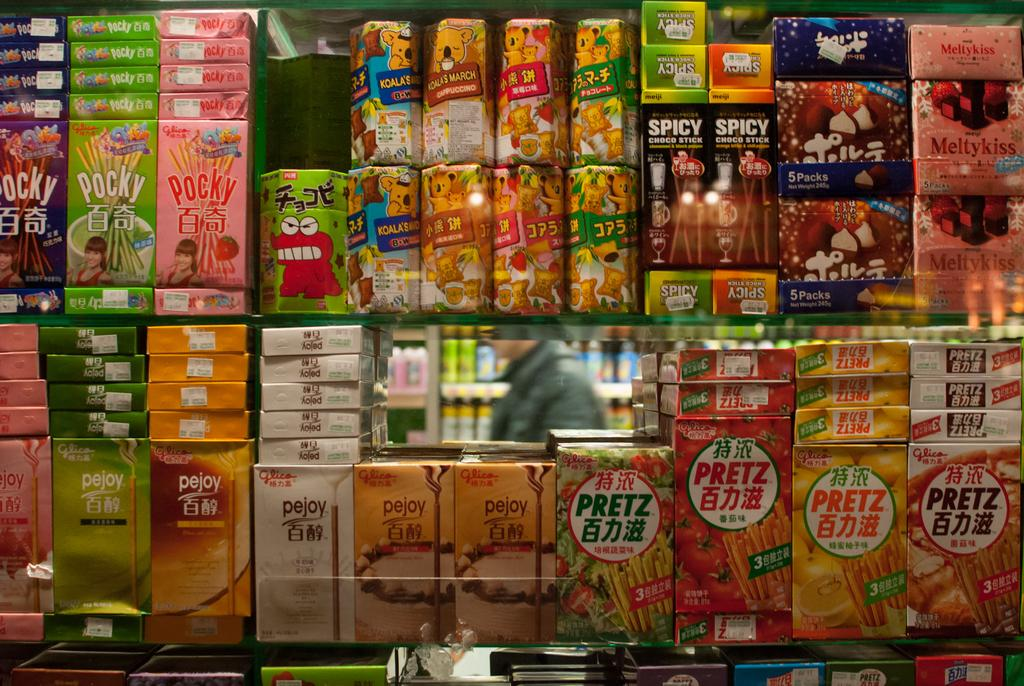<image>
Share a concise interpretation of the image provided. Many boxes shown here, the ones on the top left are called Pocky. 